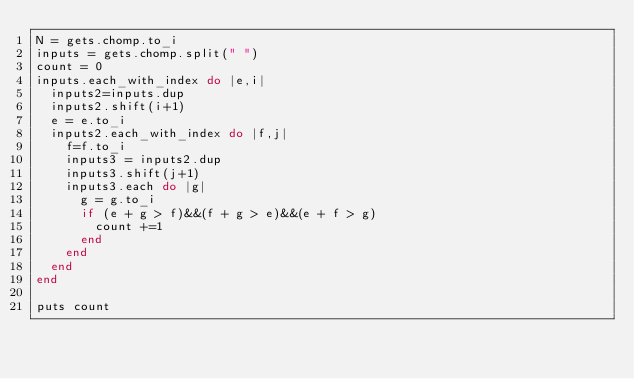<code> <loc_0><loc_0><loc_500><loc_500><_Ruby_>N = gets.chomp.to_i
inputs = gets.chomp.split(" ")
count = 0
inputs.each_with_index do |e,i|
  inputs2=inputs.dup
  inputs2.shift(i+1)
  e = e.to_i
  inputs2.each_with_index do |f,j|
    f=f.to_i
    inputs3 = inputs2.dup
    inputs3.shift(j+1)
    inputs3.each do |g|
      g = g.to_i
      if (e + g > f)&&(f + g > e)&&(e + f > g)
        count +=1
      end
    end
  end
end
 
puts count
</code> 